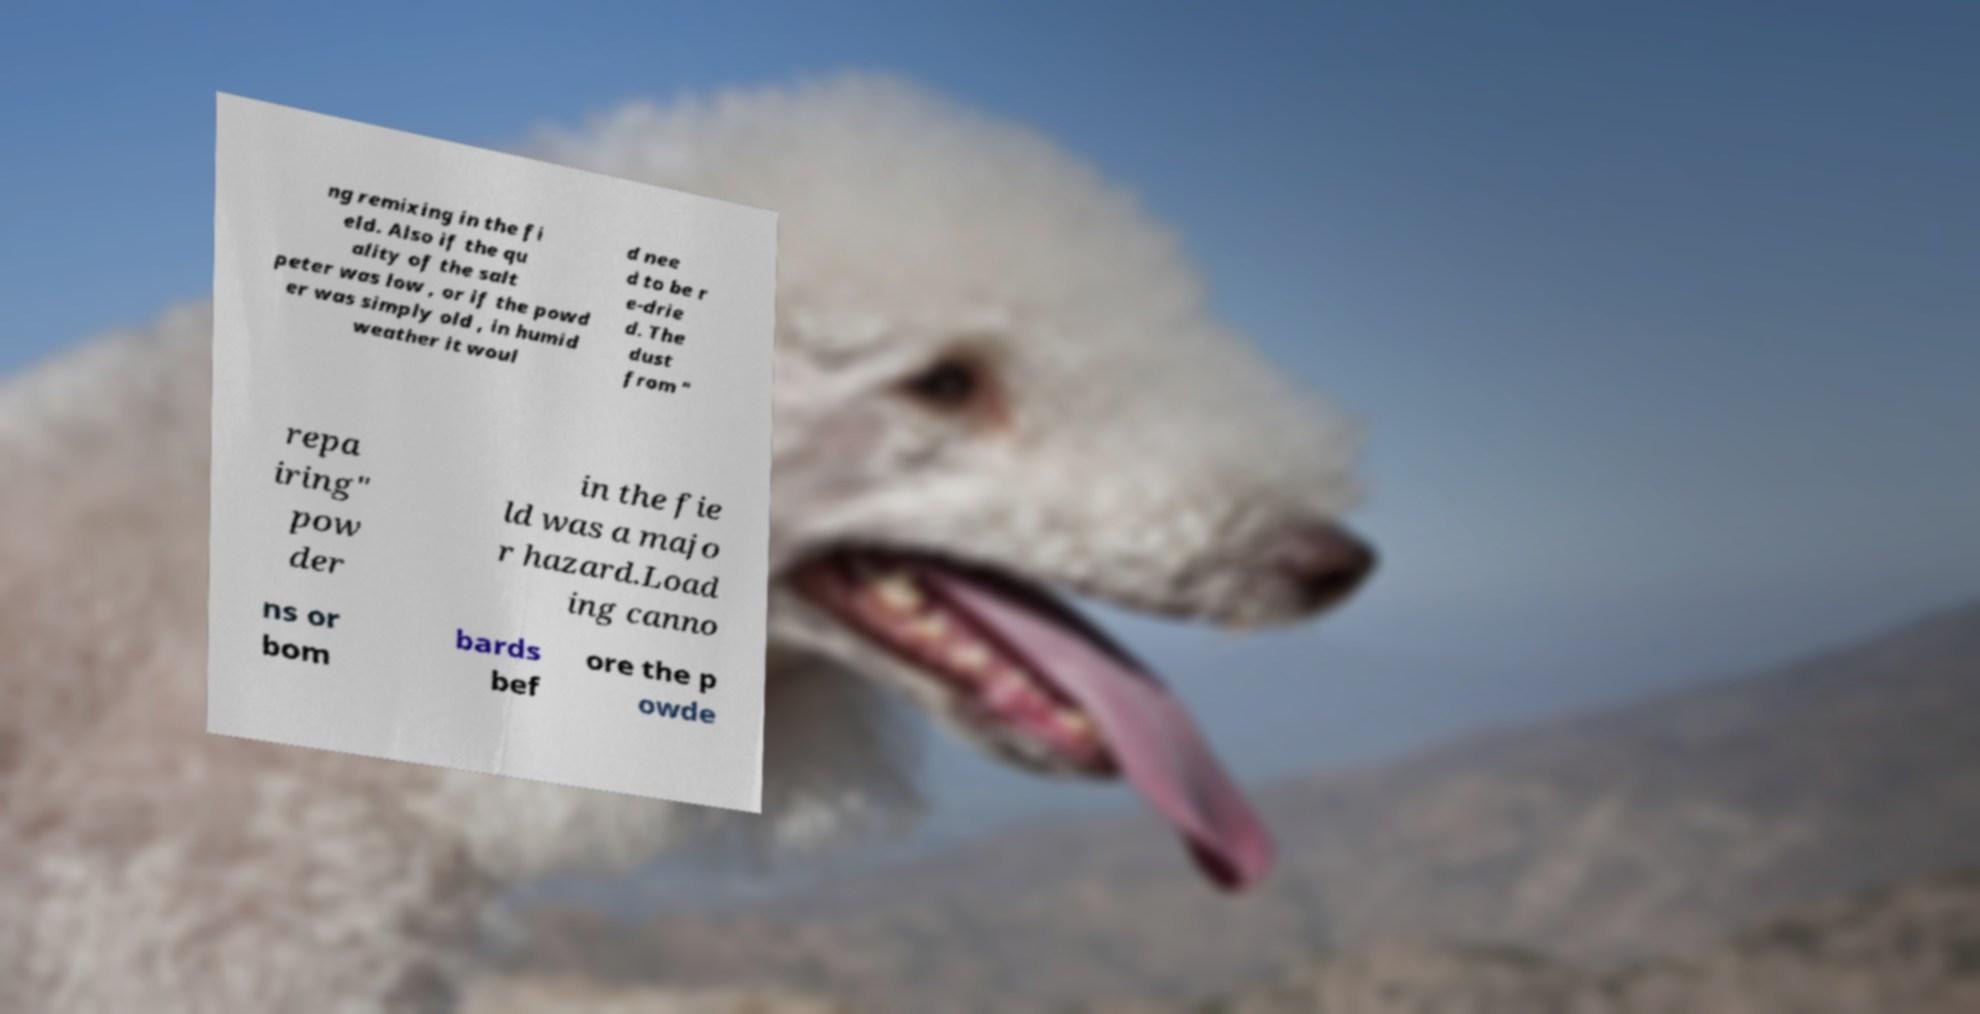There's text embedded in this image that I need extracted. Can you transcribe it verbatim? ng remixing in the fi eld. Also if the qu ality of the salt peter was low , or if the powd er was simply old , in humid weather it woul d nee d to be r e-drie d. The dust from " repa iring" pow der in the fie ld was a majo r hazard.Load ing canno ns or bom bards bef ore the p owde 